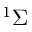Convert formula to latex. <formula><loc_0><loc_0><loc_500><loc_500>^ { 1 } \Sigma</formula> 